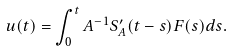<formula> <loc_0><loc_0><loc_500><loc_500>u ( t ) = \int _ { 0 } ^ { t } A ^ { - 1 } S _ { A } ^ { \prime } ( t - s ) F ( s ) d s .</formula> 